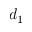Convert formula to latex. <formula><loc_0><loc_0><loc_500><loc_500>d _ { 1 }</formula> 